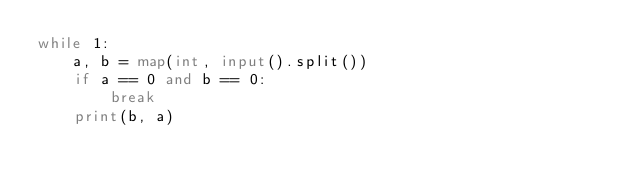Convert code to text. <code><loc_0><loc_0><loc_500><loc_500><_Python_>while 1:
    a, b = map(int, input().split())
    if a == 0 and b == 0:
        break
    print(b, a)
</code> 